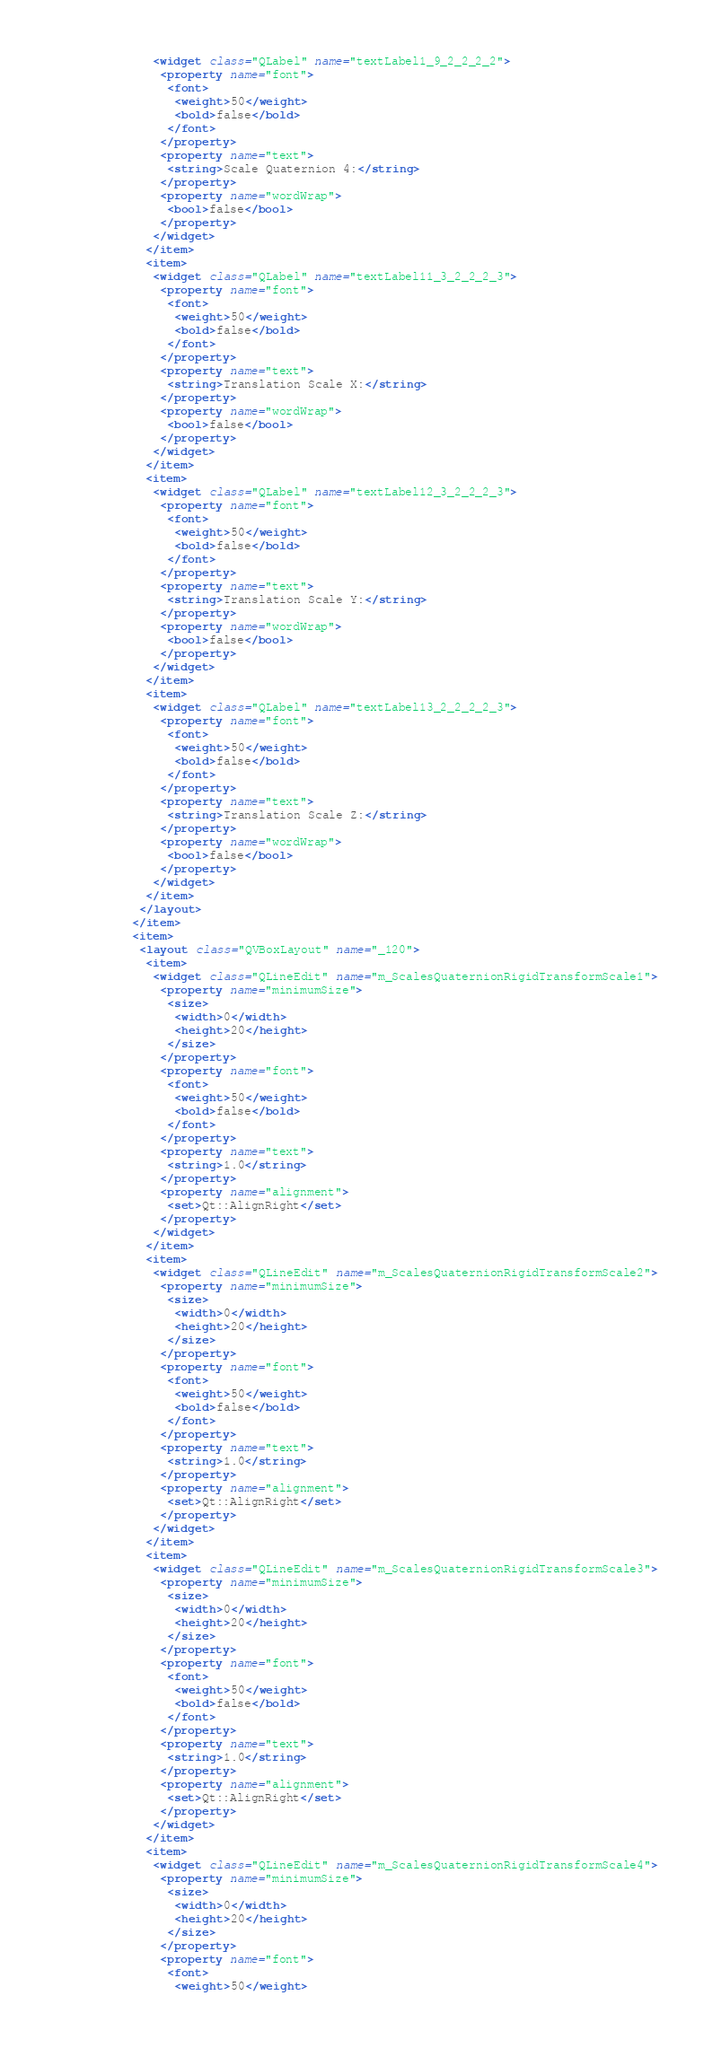Convert code to text. <code><loc_0><loc_0><loc_500><loc_500><_XML_>              <widget class="QLabel" name="textLabel1_9_2_2_2_2">
               <property name="font">
                <font>
                 <weight>50</weight>
                 <bold>false</bold>
                </font>
               </property>
               <property name="text">
                <string>Scale Quaternion 4:</string>
               </property>
               <property name="wordWrap">
                <bool>false</bool>
               </property>
              </widget>
             </item>
             <item>
              <widget class="QLabel" name="textLabel11_3_2_2_2_3">
               <property name="font">
                <font>
                 <weight>50</weight>
                 <bold>false</bold>
                </font>
               </property>
               <property name="text">
                <string>Translation Scale X:</string>
               </property>
               <property name="wordWrap">
                <bool>false</bool>
               </property>
              </widget>
             </item>
             <item>
              <widget class="QLabel" name="textLabel12_3_2_2_2_3">
               <property name="font">
                <font>
                 <weight>50</weight>
                 <bold>false</bold>
                </font>
               </property>
               <property name="text">
                <string>Translation Scale Y:</string>
               </property>
               <property name="wordWrap">
                <bool>false</bool>
               </property>
              </widget>
             </item>
             <item>
              <widget class="QLabel" name="textLabel13_2_2_2_2_3">
               <property name="font">
                <font>
                 <weight>50</weight>
                 <bold>false</bold>
                </font>
               </property>
               <property name="text">
                <string>Translation Scale Z:</string>
               </property>
               <property name="wordWrap">
                <bool>false</bool>
               </property>
              </widget>
             </item>
            </layout>
           </item>
           <item>
            <layout class="QVBoxLayout" name="_120">
             <item>
              <widget class="QLineEdit" name="m_ScalesQuaternionRigidTransformScale1">
               <property name="minimumSize">
                <size>
                 <width>0</width>
                 <height>20</height>
                </size>
               </property>
               <property name="font">
                <font>
                 <weight>50</weight>
                 <bold>false</bold>
                </font>
               </property>
               <property name="text">
                <string>1.0</string>
               </property>
               <property name="alignment">
                <set>Qt::AlignRight</set>
               </property>
              </widget>
             </item>
             <item>
              <widget class="QLineEdit" name="m_ScalesQuaternionRigidTransformScale2">
               <property name="minimumSize">
                <size>
                 <width>0</width>
                 <height>20</height>
                </size>
               </property>
               <property name="font">
                <font>
                 <weight>50</weight>
                 <bold>false</bold>
                </font>
               </property>
               <property name="text">
                <string>1.0</string>
               </property>
               <property name="alignment">
                <set>Qt::AlignRight</set>
               </property>
              </widget>
             </item>
             <item>
              <widget class="QLineEdit" name="m_ScalesQuaternionRigidTransformScale3">
               <property name="minimumSize">
                <size>
                 <width>0</width>
                 <height>20</height>
                </size>
               </property>
               <property name="font">
                <font>
                 <weight>50</weight>
                 <bold>false</bold>
                </font>
               </property>
               <property name="text">
                <string>1.0</string>
               </property>
               <property name="alignment">
                <set>Qt::AlignRight</set>
               </property>
              </widget>
             </item>
             <item>
              <widget class="QLineEdit" name="m_ScalesQuaternionRigidTransformScale4">
               <property name="minimumSize">
                <size>
                 <width>0</width>
                 <height>20</height>
                </size>
               </property>
               <property name="font">
                <font>
                 <weight>50</weight></code> 